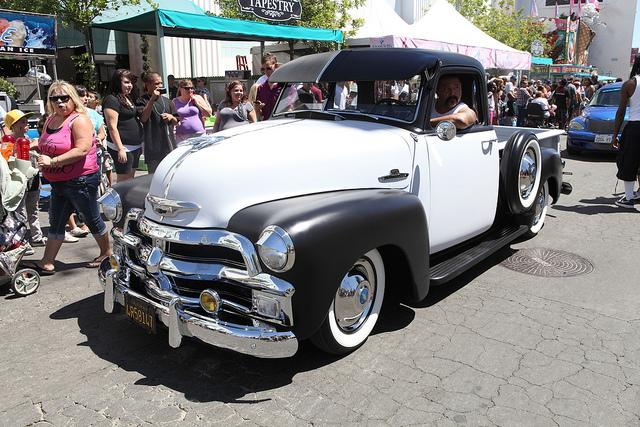Where Tapestry is located?

Choices:
A) california
B) london
C) none
D) new york new york 